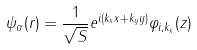<formula> <loc_0><loc_0><loc_500><loc_500>\psi _ { \alpha } ( { r } ) = \frac { 1 } { \sqrt { S } } e ^ { i ( k _ { x } x + k _ { y } y ) } \varphi _ { i , k _ { x } } ( z )</formula> 